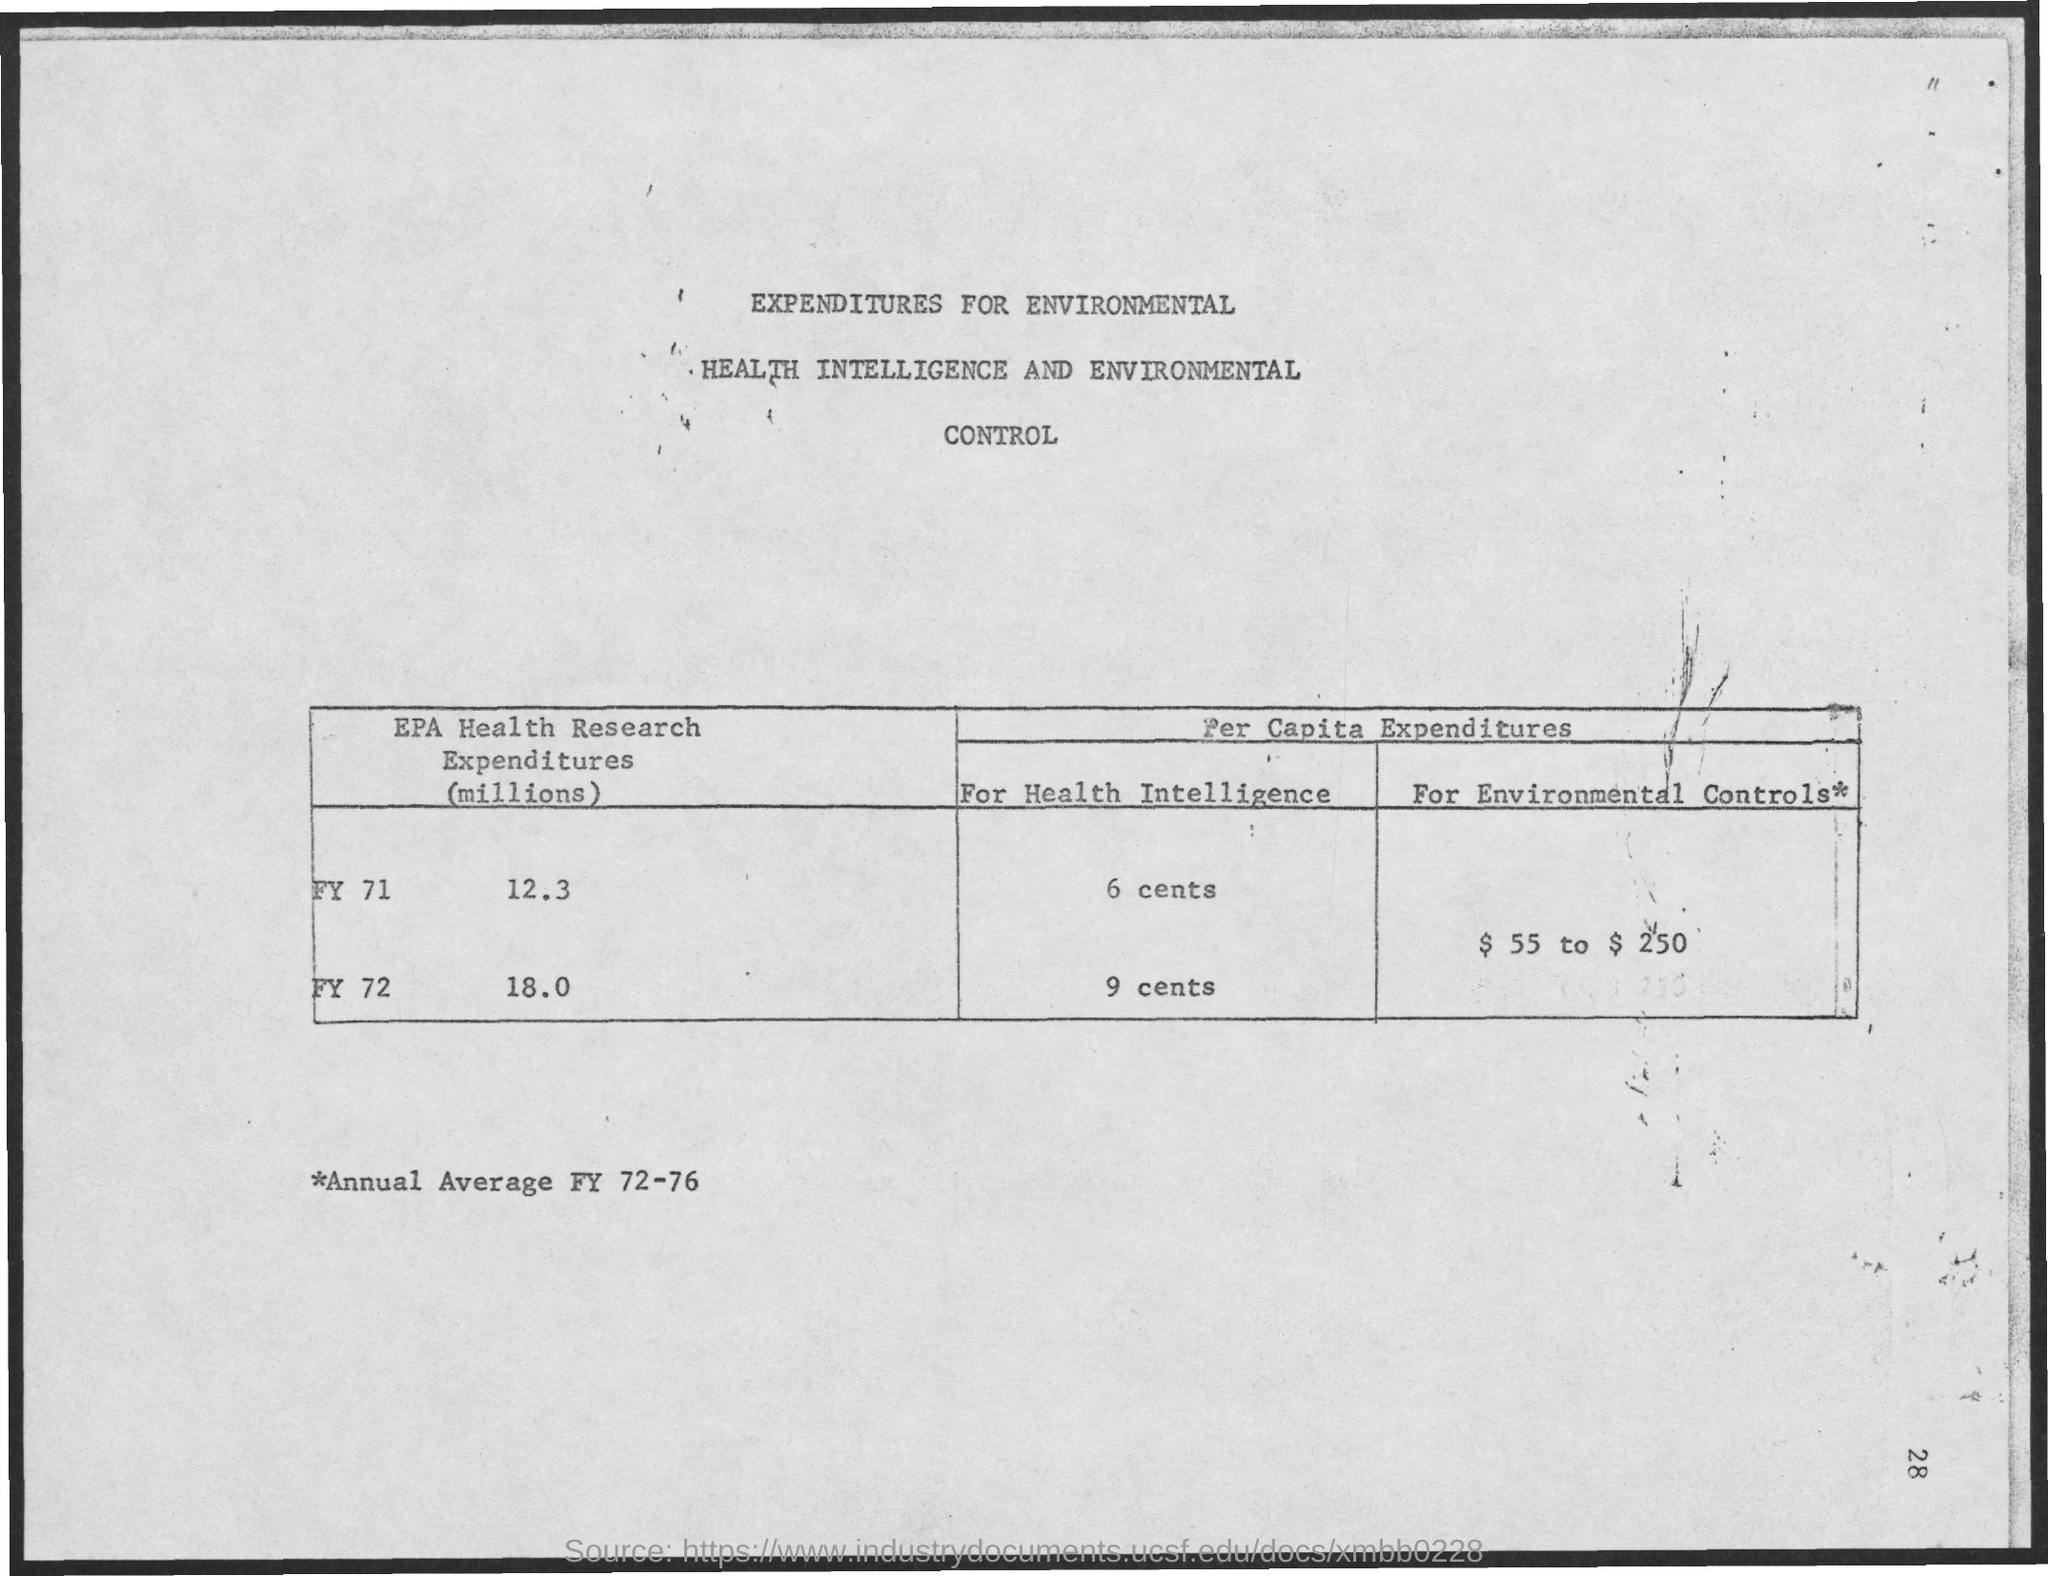Give some essential details in this illustration. The title of the document is "Expenditures for Environmental Health Intelligence and Environmental Control. 